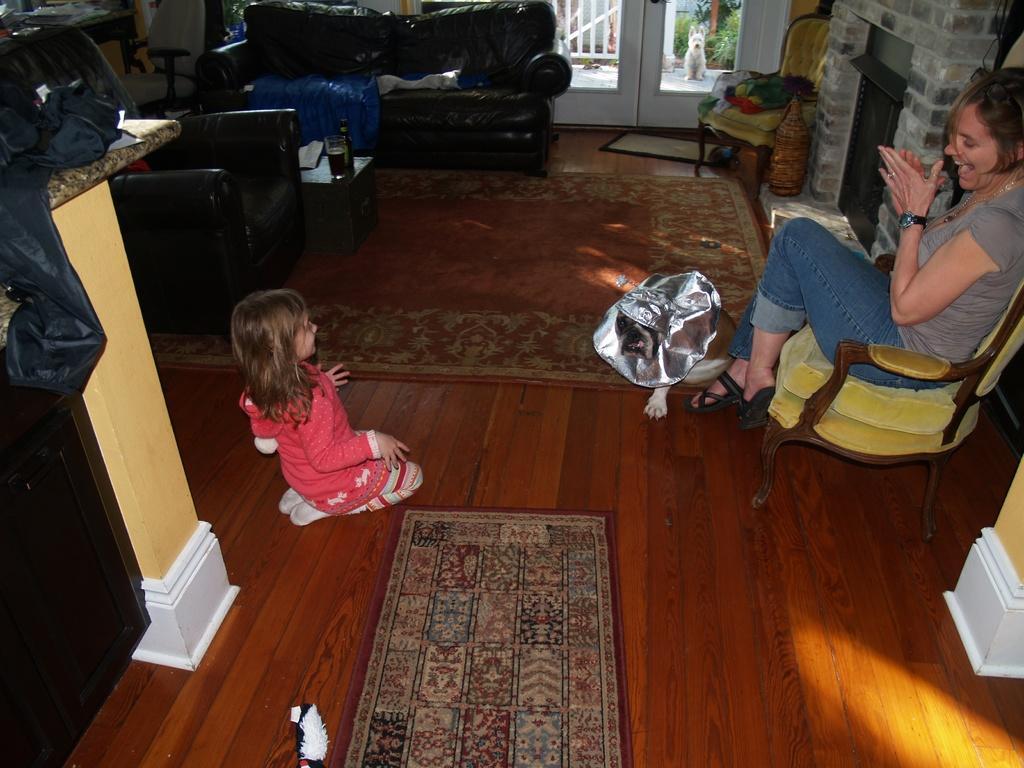Describe this image in one or two sentences. In this image there is a couch and a chair. On the table there is a glass and a bottle. On the chair the woman is sitting on the floor the child and a dog are sitting. At the background we can see the glass door. 